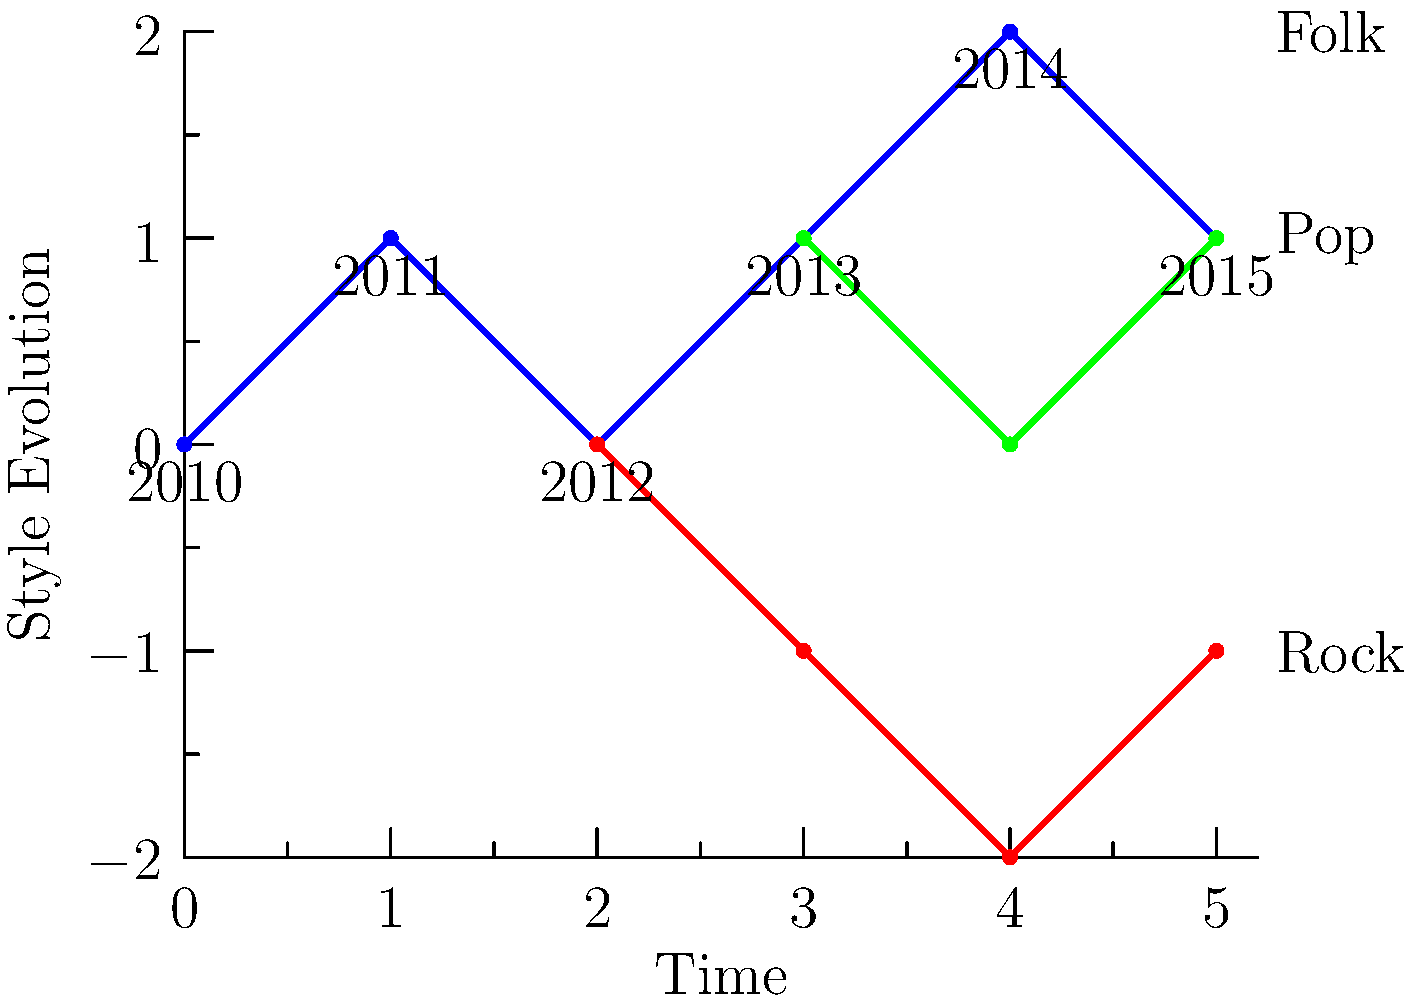The graph represents the evolution of a songwriter's style over time. The blue line shows the main style progression, while the red and green branches indicate experimentation with different genres. If the songwriter collaborated with Ankit Tiwari in 2014, which year marked the most significant divergence in style, potentially influenced by this collaboration? To answer this question, we need to analyze the graph and follow these steps:

1. Identify the year of collaboration with Ankit Tiwari: 2014 (corresponds to the 5th point on the x-axis)

2. Examine the graph for significant changes or branching points:
   - 2010-2011: Steady increase in style evolution
   - 2011-2012: Slight decrease, but no branching
   - 2012-2013: Increase with the first branching point (red line)
   - 2013-2014: Further increase with a second branching point (green line)
   - 2014-2015: Continuation of all three paths

3. Analyze the impact of the 2014 collaboration:
   - The collaboration occurred just before the 2014-2015 period
   - This period shows the most diverse range of styles, with three distinct paths

4. Identify the year with the most significant divergence:
   - 2013 marks the point where both the red and green branches emerge from the main blue line
   - This divergence represents a major shift in the songwriter's style, exploring multiple genres simultaneously

5. Consider the influence of the collaboration:
   - While the collaboration happened in 2014, its influence likely began earlier
   - The significant branching in 2013 could be attributed to preparations or discussions leading up to the collaboration

Therefore, 2013 marks the most significant divergence in style, potentially influenced by the upcoming collaboration with Ankit Tiwari in 2014.
Answer: 2013 